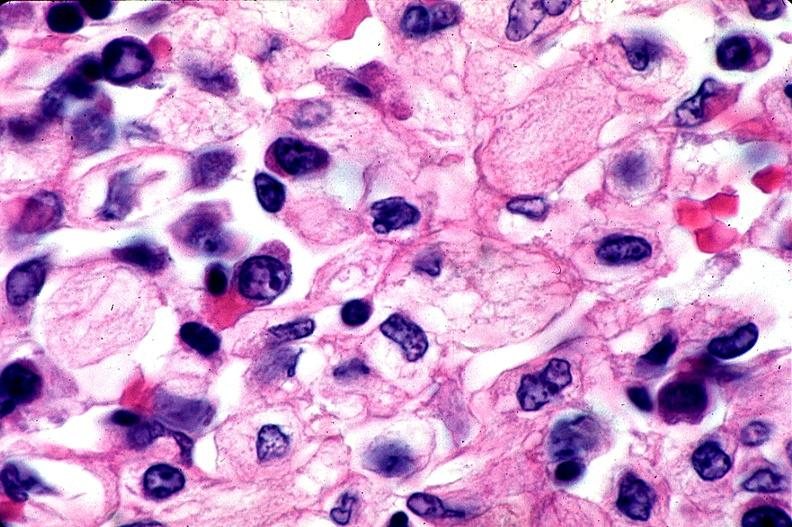does autoimmune thyroiditis show gaucher disease?
Answer the question using a single word or phrase. No 